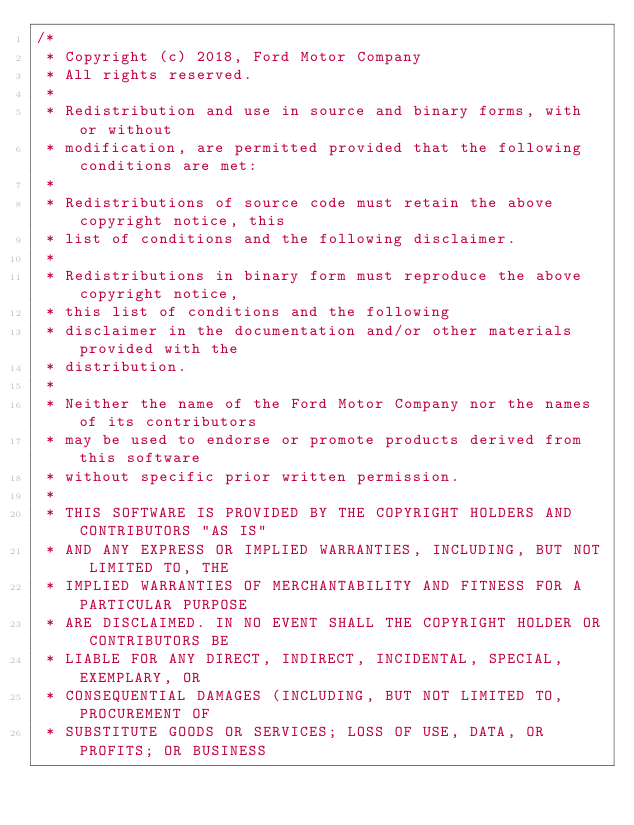Convert code to text. <code><loc_0><loc_0><loc_500><loc_500><_C_>/*
 * Copyright (c) 2018, Ford Motor Company
 * All rights reserved.
 *
 * Redistribution and use in source and binary forms, with or without
 * modification, are permitted provided that the following conditions are met:
 *
 * Redistributions of source code must retain the above copyright notice, this
 * list of conditions and the following disclaimer.
 *
 * Redistributions in binary form must reproduce the above copyright notice,
 * this list of conditions and the following
 * disclaimer in the documentation and/or other materials provided with the
 * distribution.
 *
 * Neither the name of the Ford Motor Company nor the names of its contributors
 * may be used to endorse or promote products derived from this software
 * without specific prior written permission.
 *
 * THIS SOFTWARE IS PROVIDED BY THE COPYRIGHT HOLDERS AND CONTRIBUTORS "AS IS"
 * AND ANY EXPRESS OR IMPLIED WARRANTIES, INCLUDING, BUT NOT LIMITED TO, THE
 * IMPLIED WARRANTIES OF MERCHANTABILITY AND FITNESS FOR A PARTICULAR PURPOSE
 * ARE DISCLAIMED. IN NO EVENT SHALL THE COPYRIGHT HOLDER OR CONTRIBUTORS BE
 * LIABLE FOR ANY DIRECT, INDIRECT, INCIDENTAL, SPECIAL, EXEMPLARY, OR
 * CONSEQUENTIAL DAMAGES (INCLUDING, BUT NOT LIMITED TO, PROCUREMENT OF
 * SUBSTITUTE GOODS OR SERVICES; LOSS OF USE, DATA, OR PROFITS; OR BUSINESS</code> 